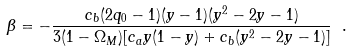<formula> <loc_0><loc_0><loc_500><loc_500>\beta = - \frac { c _ { b } ( 2 q _ { 0 } - 1 ) ( y - 1 ) ( y ^ { 2 } - 2 y - 1 ) } { 3 ( 1 - \Omega _ { M } ) [ c _ { a } y ( 1 - y ) + c _ { b } ( y ^ { 2 } - 2 y - 1 ) ] } \ .</formula> 